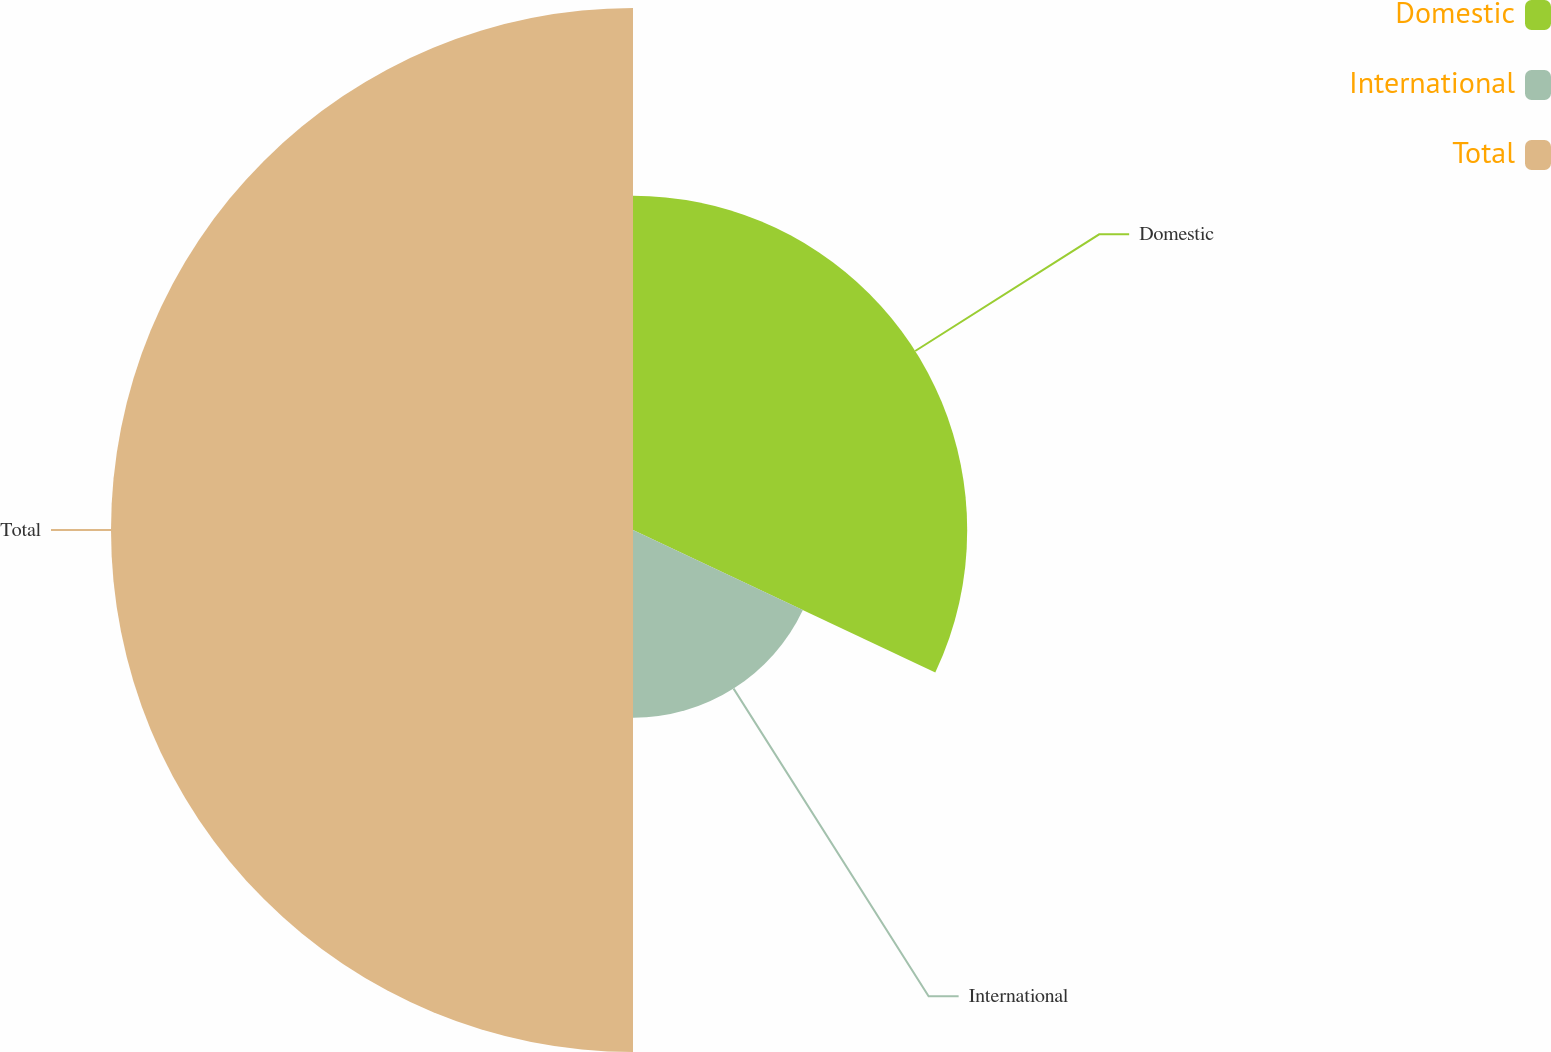Convert chart. <chart><loc_0><loc_0><loc_500><loc_500><pie_chart><fcel>Domestic<fcel>International<fcel>Total<nl><fcel>32.01%<fcel>17.99%<fcel>50.0%<nl></chart> 